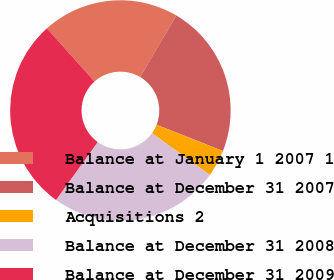Convert chart. <chart><loc_0><loc_0><loc_500><loc_500><pie_chart><fcel>Balance at January 1 2007 1<fcel>Balance at December 31 2007<fcel>Acquisitions 2<fcel>Balance at December 31 2008<fcel>Balance at December 31 2009<nl><fcel>20.08%<fcel>22.53%<fcel>3.96%<fcel>24.98%<fcel>28.46%<nl></chart> 